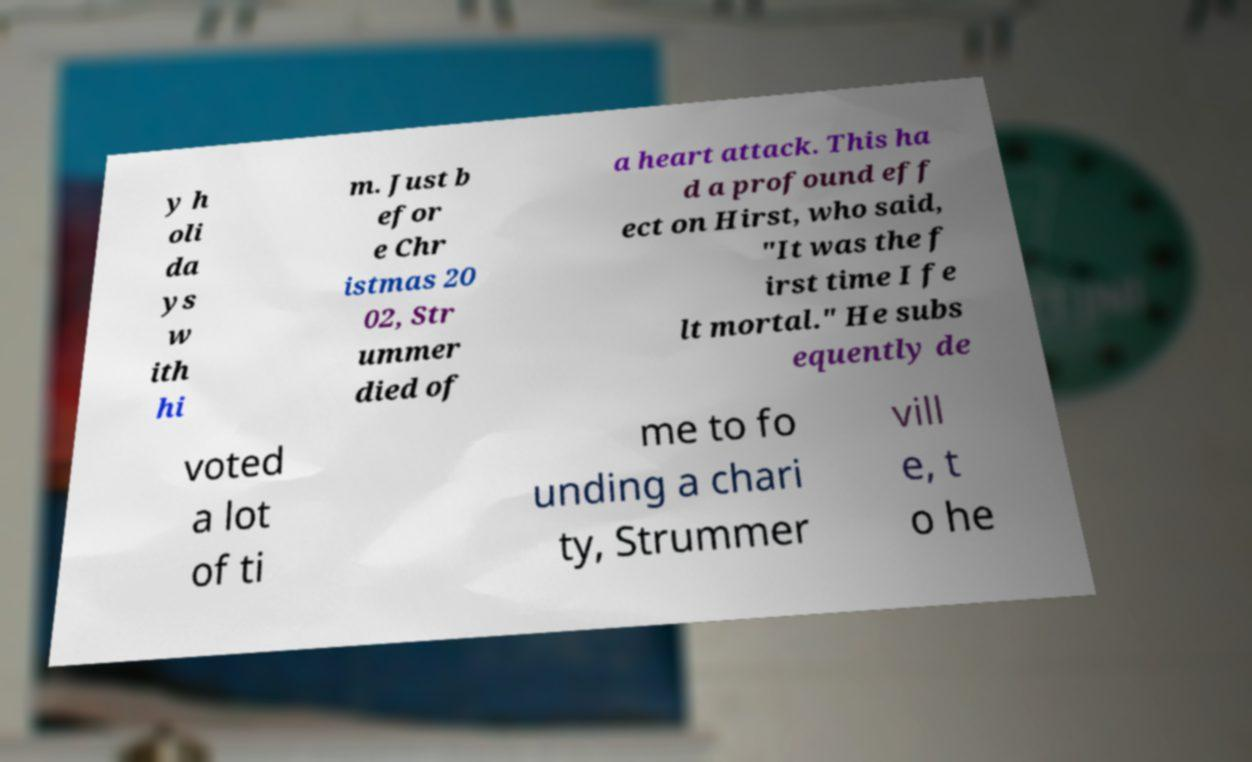There's text embedded in this image that I need extracted. Can you transcribe it verbatim? y h oli da ys w ith hi m. Just b efor e Chr istmas 20 02, Str ummer died of a heart attack. This ha d a profound eff ect on Hirst, who said, "It was the f irst time I fe lt mortal." He subs equently de voted a lot of ti me to fo unding a chari ty, Strummer vill e, t o he 